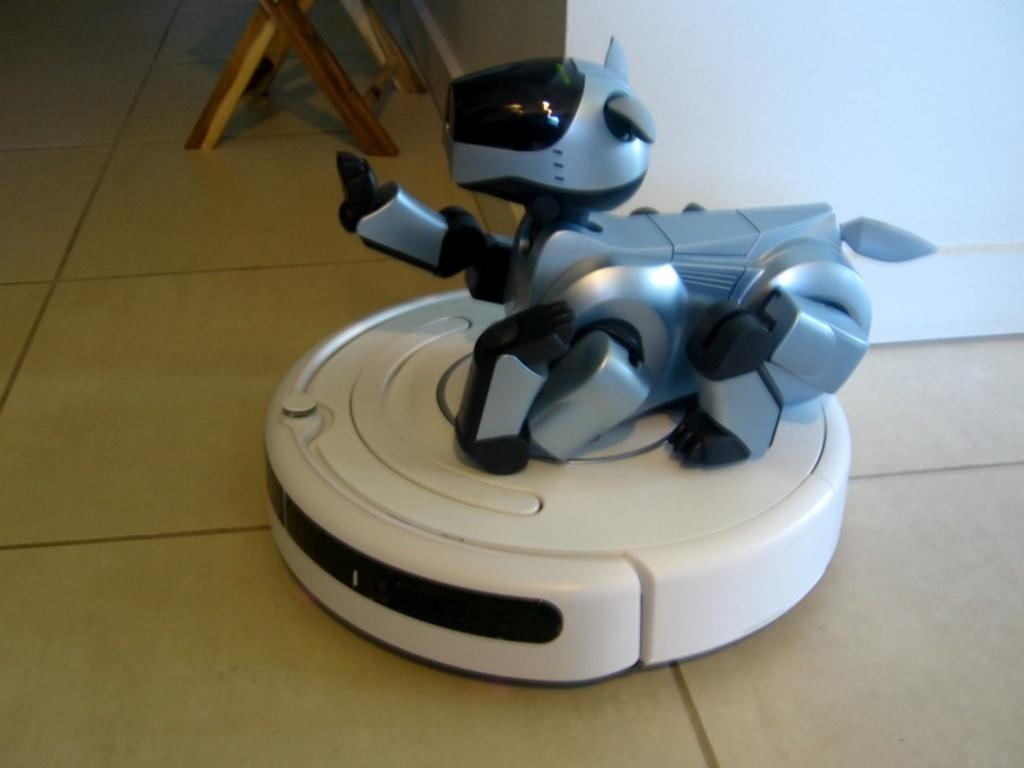What is the main subject in the image? There is a robot in the image. Where is the robot located? The robot is on a white object. What can be inferred about the white object? The white object is on the floor. What can be seen in the background of the image? There is a wall and a wooden chair in the background of the image. How many dimes are on the floor next to the robot? There are no dimes visible in the image; the focus is on the robot and the white object it is on. 